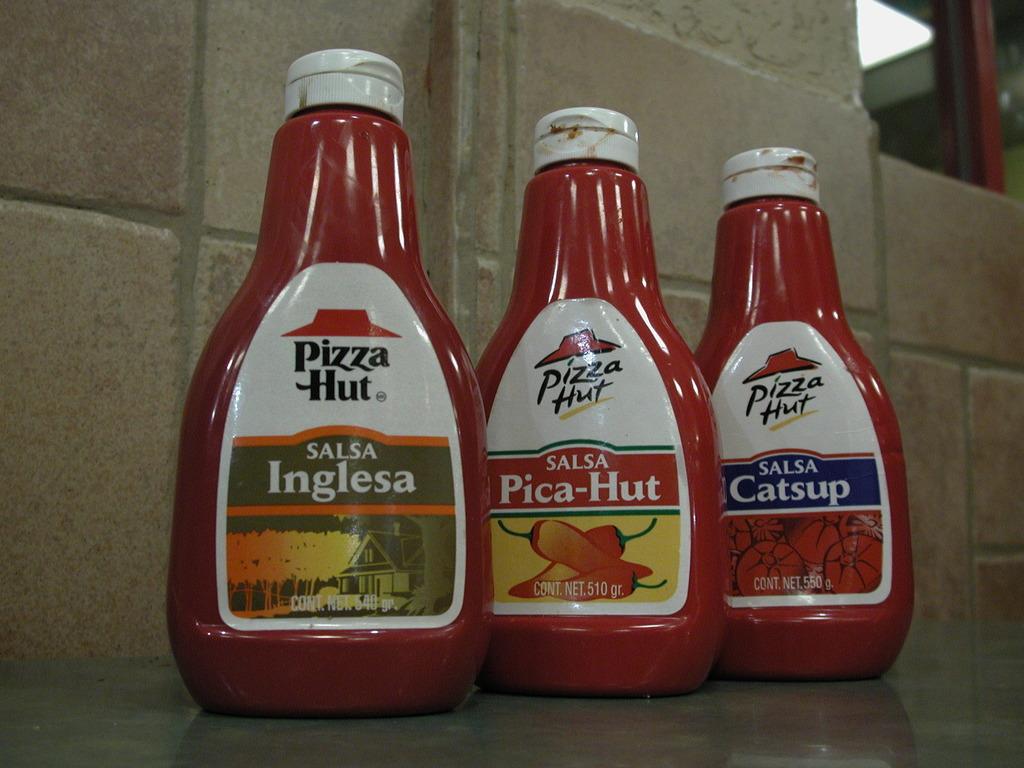Does pizza hut make their own sauces?
Provide a succinct answer. Yes. What is the company who makes the products in the red bottles?
Give a very brief answer. Pizza hut. 